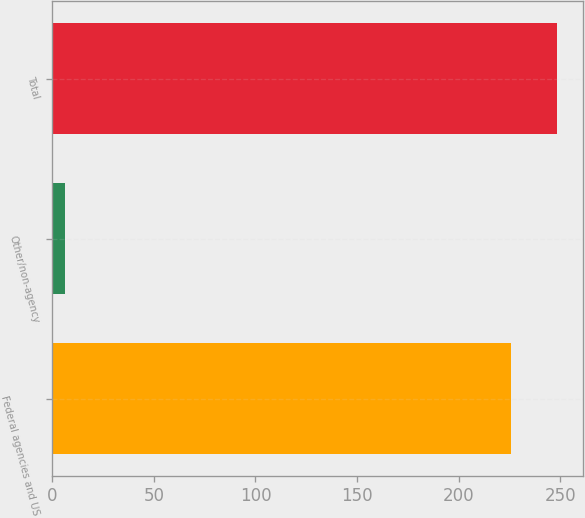Convert chart. <chart><loc_0><loc_0><loc_500><loc_500><bar_chart><fcel>Federal agencies and US<fcel>Other/non-agency<fcel>Total<nl><fcel>226<fcel>6<fcel>248.6<nl></chart> 